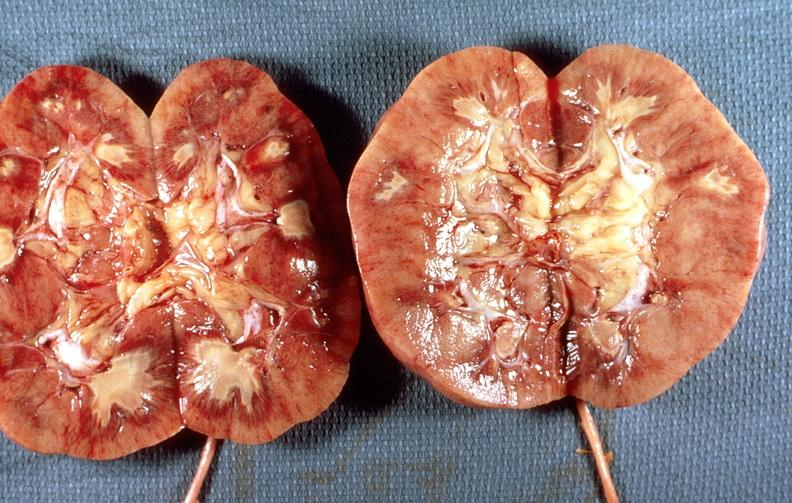where is this?
Answer the question using a single word or phrase. Urinary 